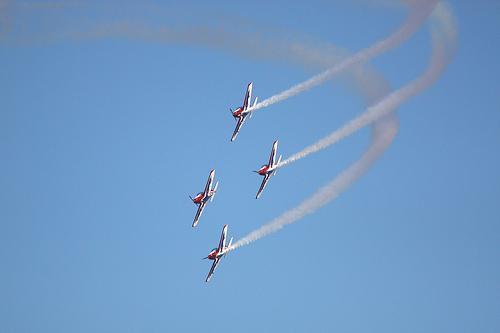How many airplanes?
Give a very brief answer. 4. How many planes have a trail of smoke?
Give a very brief answer. 3. 